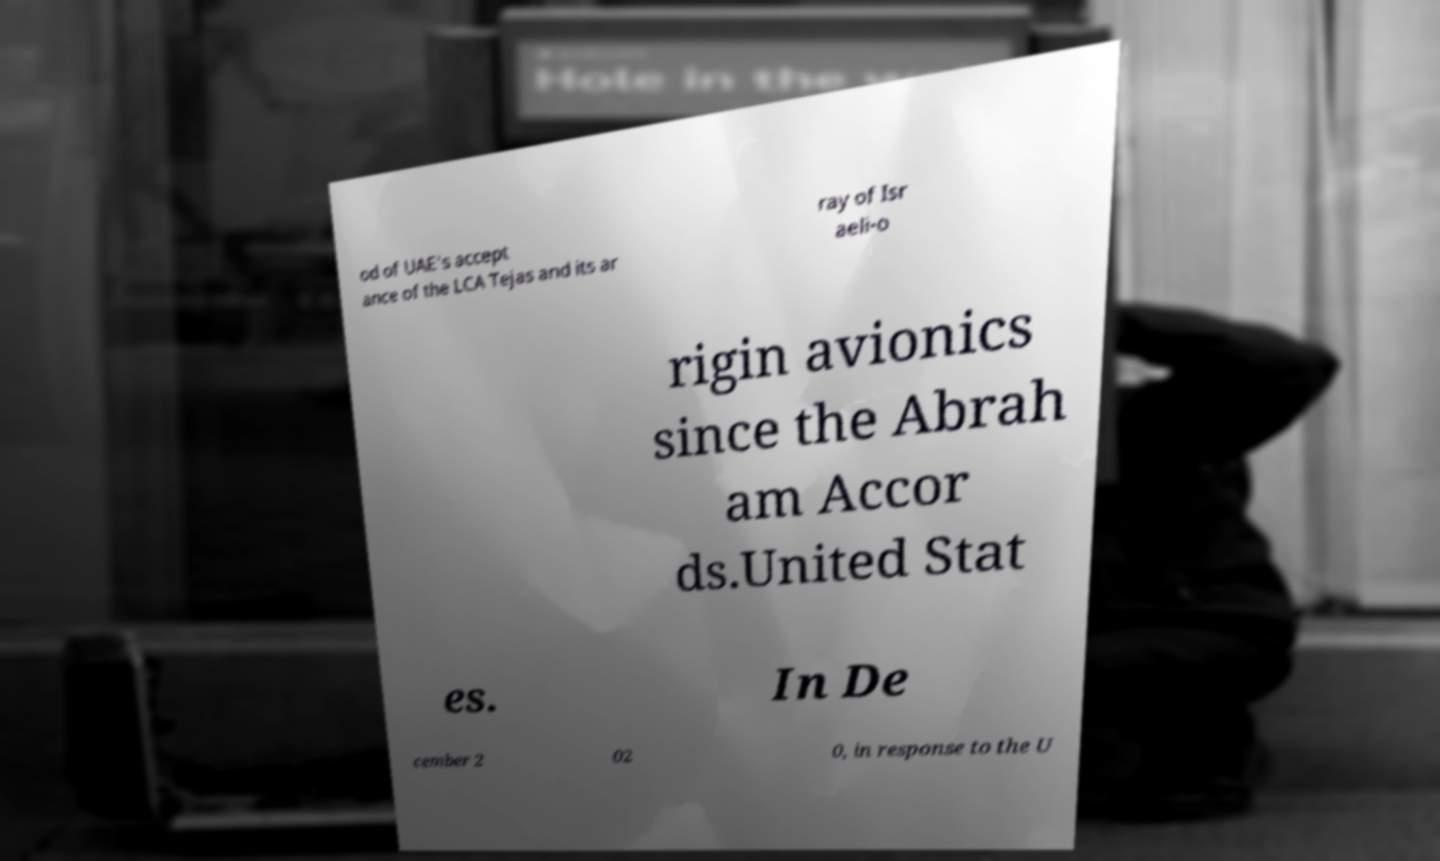Can you read and provide the text displayed in the image?This photo seems to have some interesting text. Can you extract and type it out for me? od of UAE's accept ance of the LCA Tejas and its ar ray of Isr aeli-o rigin avionics since the Abrah am Accor ds.United Stat es. In De cember 2 02 0, in response to the U 